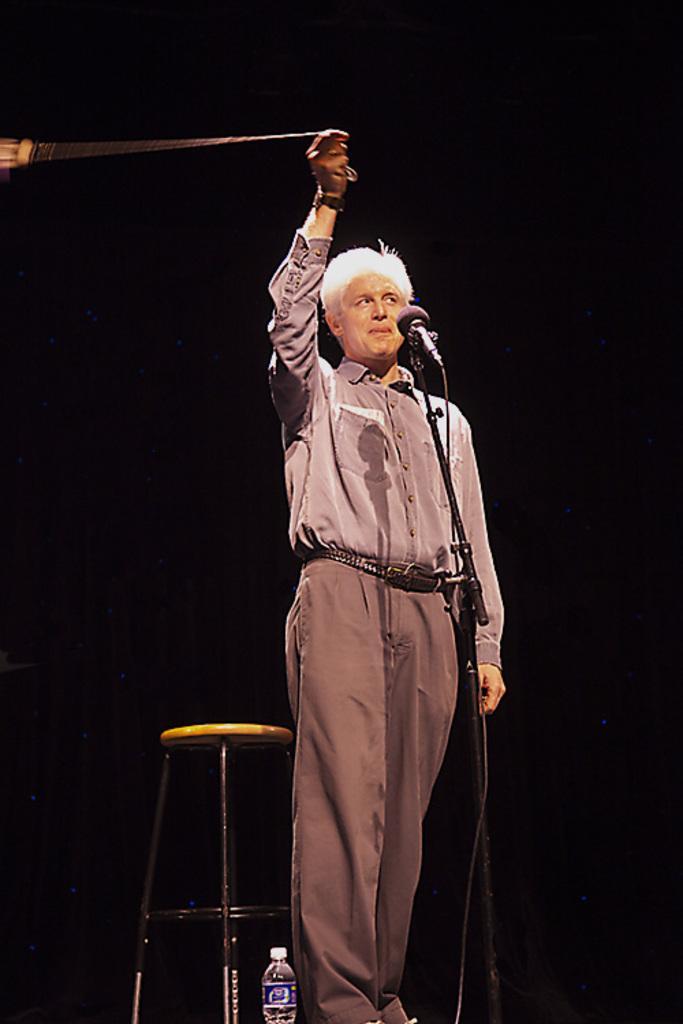Please provide a concise description of this image. In the middle of the image a man is standing and he is holding an object in his hand. There is a mic. There is a stool and there is a water bottle. In this image the background is black in color. 